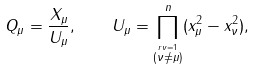Convert formula to latex. <formula><loc_0><loc_0><loc_500><loc_500>Q _ { \mu } = \frac { X _ { \mu } } { U _ { \mu } } , \quad U _ { \mu } = \prod _ { \stackrel { r \nu = 1 } { ( \nu \neq \mu ) } } ^ { n } ( x _ { \mu } ^ { 2 } - x _ { \nu } ^ { 2 } ) ,</formula> 